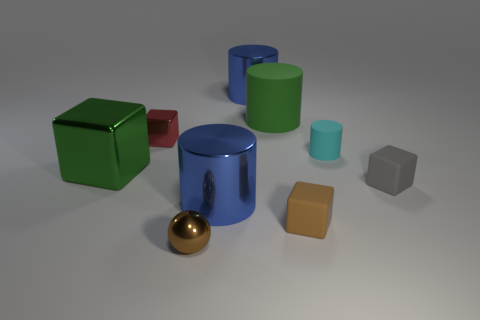Subtract all cyan blocks. Subtract all cyan cylinders. How many blocks are left? 4 Add 1 big blue cylinders. How many objects exist? 10 Subtract all blocks. How many objects are left? 5 Add 4 metal cubes. How many metal cubes are left? 6 Add 4 large blue shiny objects. How many large blue shiny objects exist? 6 Subtract 1 green blocks. How many objects are left? 8 Subtract all big rubber spheres. Subtract all blue shiny objects. How many objects are left? 7 